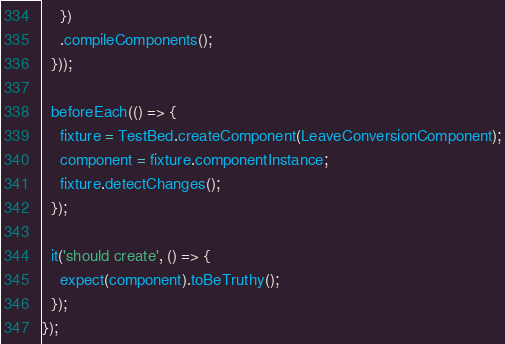Convert code to text. <code><loc_0><loc_0><loc_500><loc_500><_TypeScript_>    })
    .compileComponents();
  }));

  beforeEach(() => {
    fixture = TestBed.createComponent(LeaveConversionComponent);
    component = fixture.componentInstance;
    fixture.detectChanges();
  });

  it('should create', () => {
    expect(component).toBeTruthy();
  });
});
</code> 